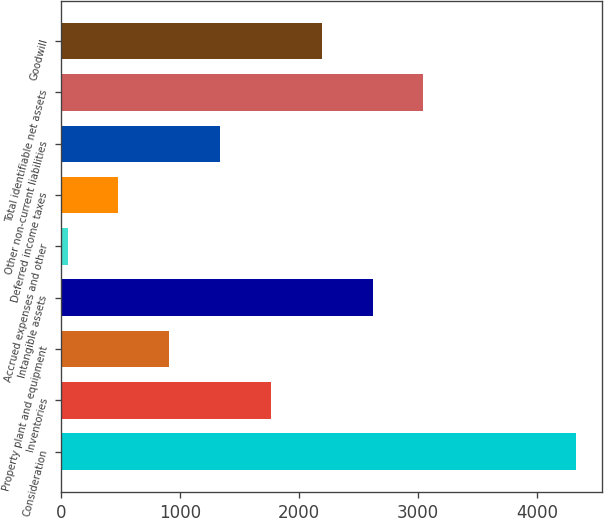Convert chart. <chart><loc_0><loc_0><loc_500><loc_500><bar_chart><fcel>Consideration<fcel>Inventories<fcel>Property plant and equipment<fcel>Intangible assets<fcel>Accrued expenses and other<fcel>Deferred income taxes<fcel>Other non-current liabilities<fcel>Total identifiable net assets<fcel>Goodwill<nl><fcel>4330<fcel>1764.4<fcel>909.2<fcel>2619.6<fcel>54<fcel>481.6<fcel>1336.8<fcel>3047.2<fcel>2192<nl></chart> 